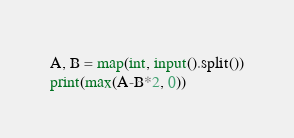<code> <loc_0><loc_0><loc_500><loc_500><_Python_>A, B = map(int, input().split())
print(max(A-B*2, 0))</code> 